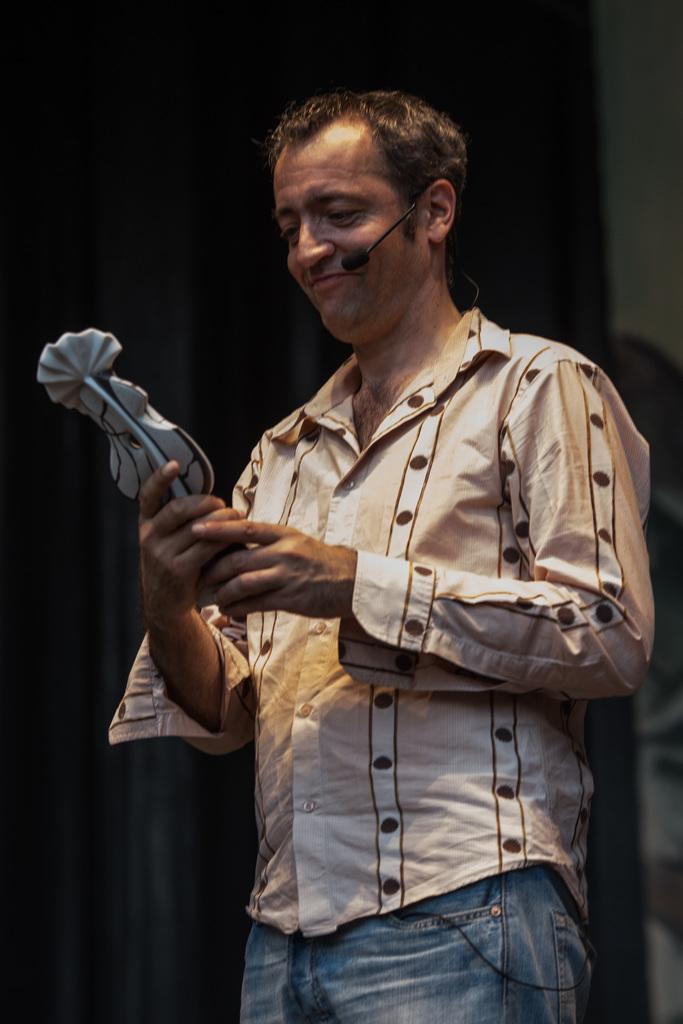What is the main subject of the image? There is a person in the image. What is the person doing in the image? The person is standing and holding something in their hands. Can you describe any additional details about the person? The person has a microphone on their ear and is smiling. What type of plane can be seen flying over the seashore in the image? There is no plane or seashore present in the image; it features a person standing with a microphone on their ear and a smile. What color is the sand at the seashore in the image? There is no seashore present in the image, so it is not possible to determine the color of the sand. 